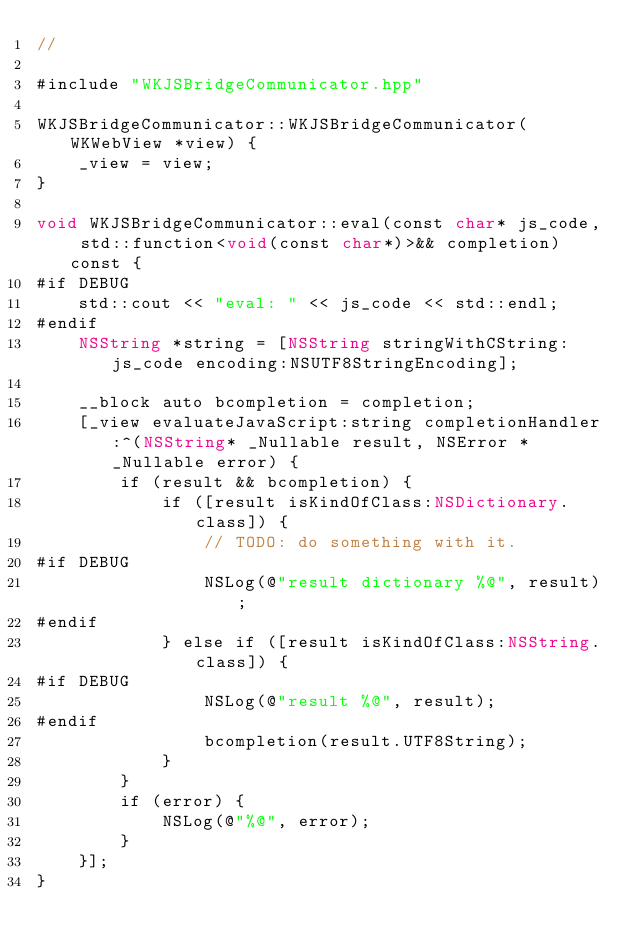Convert code to text. <code><loc_0><loc_0><loc_500><loc_500><_ObjectiveC_>//

#include "WKJSBridgeCommunicator.hpp"

WKJSBridgeCommunicator::WKJSBridgeCommunicator(WKWebView *view) {
    _view = view;
}

void WKJSBridgeCommunicator::eval(const char* js_code, std::function<void(const char*)>&& completion) const {
#if DEBUG
    std::cout << "eval: " << js_code << std::endl;
#endif
    NSString *string = [NSString stringWithCString:js_code encoding:NSUTF8StringEncoding];
    
    __block auto bcompletion = completion; 
    [_view evaluateJavaScript:string completionHandler:^(NSString* _Nullable result, NSError * _Nullable error) {
        if (result && bcompletion) {
            if ([result isKindOfClass:NSDictionary.class]) {
                // TODO: do something with it.
#if DEBUG
                NSLog(@"result dictionary %@", result);
#endif
            } else if ([result isKindOfClass:NSString.class]) {
#if DEBUG
                NSLog(@"result %@", result);
#endif
                bcompletion(result.UTF8String);
            }
        }
        if (error) {
            NSLog(@"%@", error);
        }
    }];
}
</code> 